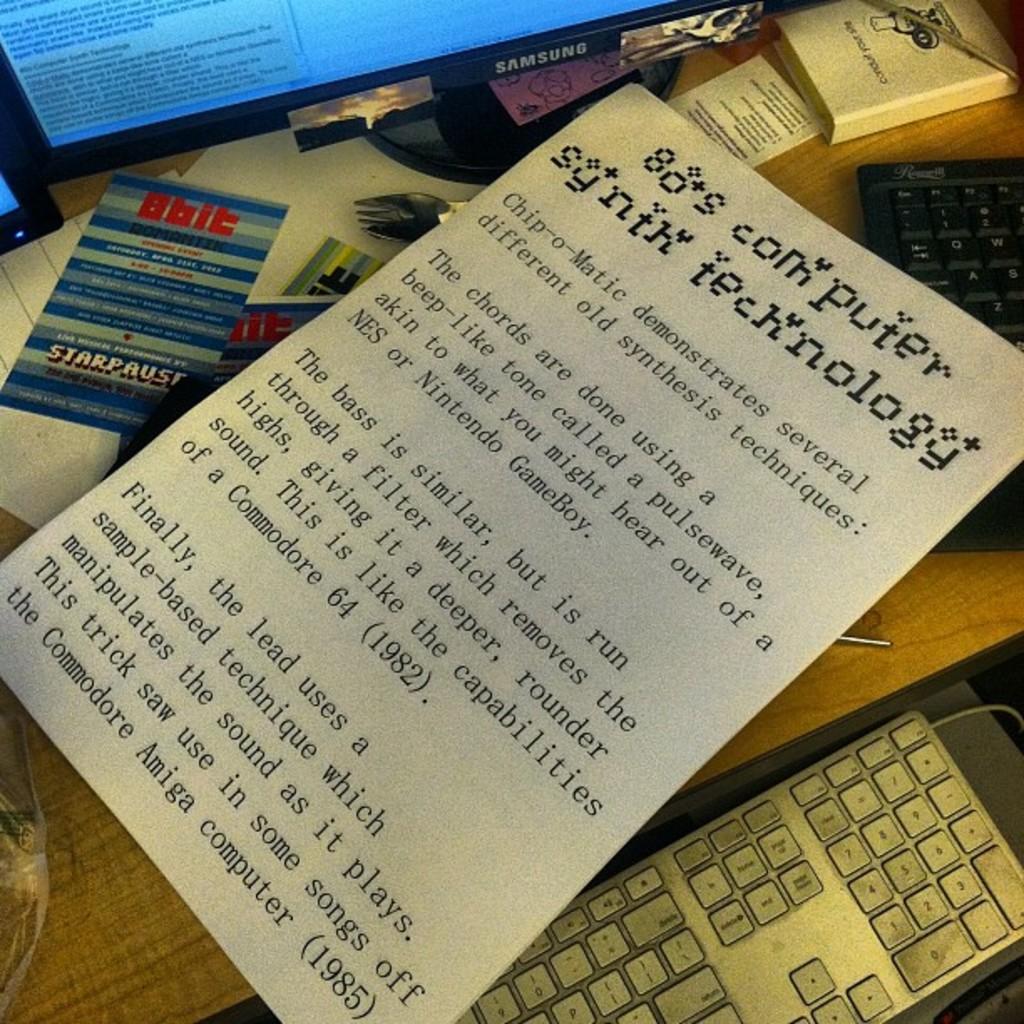What year computer are the songs taken from?
Your response must be concise. 1985. What is the title of the paper?
Your answer should be compact. 80's computer synth technology. 